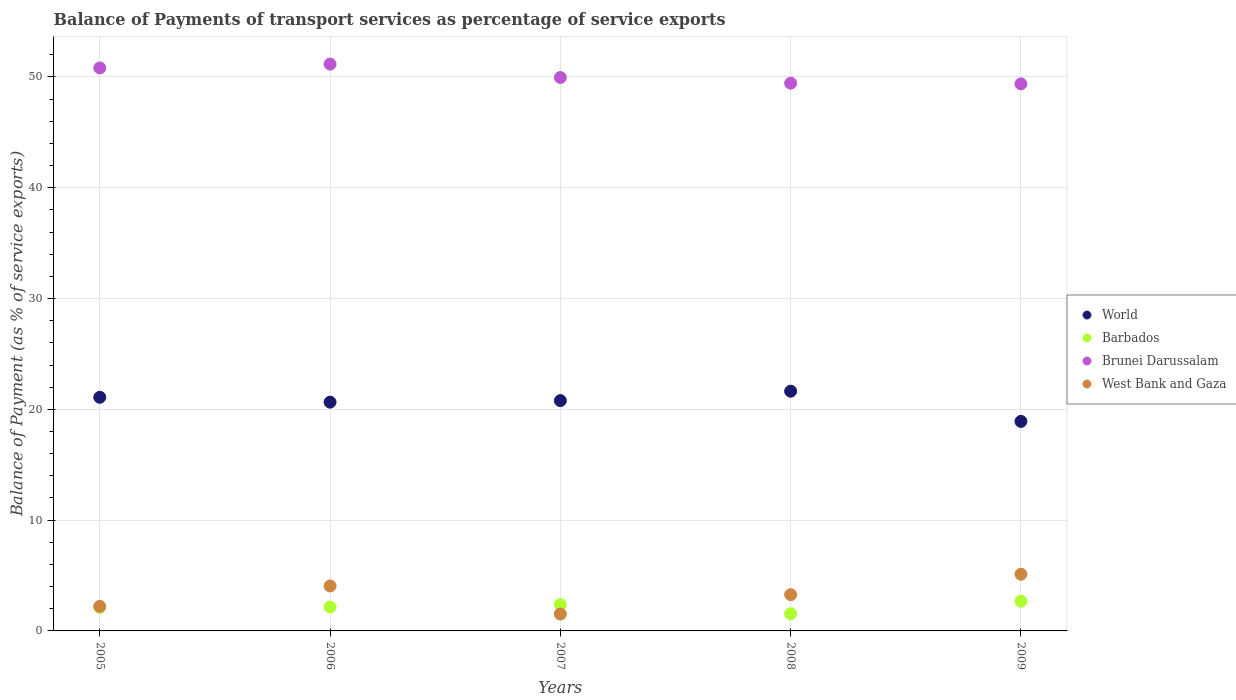How many different coloured dotlines are there?
Ensure brevity in your answer.  4. What is the balance of payments of transport services in World in 2007?
Provide a succinct answer. 20.79. Across all years, what is the maximum balance of payments of transport services in Barbados?
Provide a short and direct response. 2.68. Across all years, what is the minimum balance of payments of transport services in Barbados?
Keep it short and to the point. 1.55. In which year was the balance of payments of transport services in Brunei Darussalam maximum?
Ensure brevity in your answer.  2006. In which year was the balance of payments of transport services in Brunei Darussalam minimum?
Keep it short and to the point. 2009. What is the total balance of payments of transport services in West Bank and Gaza in the graph?
Your answer should be very brief. 16.19. What is the difference between the balance of payments of transport services in West Bank and Gaza in 2005 and that in 2009?
Your answer should be very brief. -2.9. What is the difference between the balance of payments of transport services in World in 2007 and the balance of payments of transport services in Brunei Darussalam in 2009?
Provide a short and direct response. -28.59. What is the average balance of payments of transport services in World per year?
Keep it short and to the point. 20.61. In the year 2009, what is the difference between the balance of payments of transport services in Brunei Darussalam and balance of payments of transport services in West Bank and Gaza?
Offer a terse response. 44.26. What is the ratio of the balance of payments of transport services in Barbados in 2007 to that in 2009?
Your answer should be very brief. 0.88. What is the difference between the highest and the second highest balance of payments of transport services in World?
Ensure brevity in your answer.  0.55. What is the difference between the highest and the lowest balance of payments of transport services in World?
Give a very brief answer. 2.73. Is the sum of the balance of payments of transport services in Brunei Darussalam in 2006 and 2007 greater than the maximum balance of payments of transport services in Barbados across all years?
Your answer should be compact. Yes. Is it the case that in every year, the sum of the balance of payments of transport services in Brunei Darussalam and balance of payments of transport services in World  is greater than the balance of payments of transport services in West Bank and Gaza?
Your response must be concise. Yes. Is the balance of payments of transport services in World strictly greater than the balance of payments of transport services in West Bank and Gaza over the years?
Give a very brief answer. Yes. How many dotlines are there?
Your response must be concise. 4. What is the difference between two consecutive major ticks on the Y-axis?
Keep it short and to the point. 10. Are the values on the major ticks of Y-axis written in scientific E-notation?
Offer a terse response. No. Does the graph contain grids?
Keep it short and to the point. Yes. Where does the legend appear in the graph?
Your answer should be compact. Center right. How are the legend labels stacked?
Give a very brief answer. Vertical. What is the title of the graph?
Your response must be concise. Balance of Payments of transport services as percentage of service exports. Does "Solomon Islands" appear as one of the legend labels in the graph?
Your answer should be compact. No. What is the label or title of the X-axis?
Give a very brief answer. Years. What is the label or title of the Y-axis?
Give a very brief answer. Balance of Payment (as % of service exports). What is the Balance of Payment (as % of service exports) of World in 2005?
Ensure brevity in your answer.  21.09. What is the Balance of Payment (as % of service exports) in Barbados in 2005?
Your answer should be very brief. 2.13. What is the Balance of Payment (as % of service exports) of Brunei Darussalam in 2005?
Your answer should be very brief. 50.81. What is the Balance of Payment (as % of service exports) of West Bank and Gaza in 2005?
Offer a very short reply. 2.21. What is the Balance of Payment (as % of service exports) of World in 2006?
Ensure brevity in your answer.  20.65. What is the Balance of Payment (as % of service exports) of Barbados in 2006?
Ensure brevity in your answer.  2.15. What is the Balance of Payment (as % of service exports) in Brunei Darussalam in 2006?
Ensure brevity in your answer.  51.16. What is the Balance of Payment (as % of service exports) of West Bank and Gaza in 2006?
Ensure brevity in your answer.  4.06. What is the Balance of Payment (as % of service exports) in World in 2007?
Keep it short and to the point. 20.79. What is the Balance of Payment (as % of service exports) in Barbados in 2007?
Provide a succinct answer. 2.37. What is the Balance of Payment (as % of service exports) in Brunei Darussalam in 2007?
Your response must be concise. 49.95. What is the Balance of Payment (as % of service exports) of West Bank and Gaza in 2007?
Your answer should be very brief. 1.53. What is the Balance of Payment (as % of service exports) of World in 2008?
Offer a very short reply. 21.64. What is the Balance of Payment (as % of service exports) of Barbados in 2008?
Make the answer very short. 1.55. What is the Balance of Payment (as % of service exports) in Brunei Darussalam in 2008?
Your response must be concise. 49.44. What is the Balance of Payment (as % of service exports) of West Bank and Gaza in 2008?
Provide a succinct answer. 3.27. What is the Balance of Payment (as % of service exports) of World in 2009?
Make the answer very short. 18.91. What is the Balance of Payment (as % of service exports) of Barbados in 2009?
Offer a very short reply. 2.68. What is the Balance of Payment (as % of service exports) of Brunei Darussalam in 2009?
Provide a succinct answer. 49.38. What is the Balance of Payment (as % of service exports) in West Bank and Gaza in 2009?
Provide a short and direct response. 5.12. Across all years, what is the maximum Balance of Payment (as % of service exports) in World?
Offer a terse response. 21.64. Across all years, what is the maximum Balance of Payment (as % of service exports) in Barbados?
Provide a succinct answer. 2.68. Across all years, what is the maximum Balance of Payment (as % of service exports) in Brunei Darussalam?
Offer a very short reply. 51.16. Across all years, what is the maximum Balance of Payment (as % of service exports) in West Bank and Gaza?
Ensure brevity in your answer.  5.12. Across all years, what is the minimum Balance of Payment (as % of service exports) of World?
Your response must be concise. 18.91. Across all years, what is the minimum Balance of Payment (as % of service exports) of Barbados?
Offer a very short reply. 1.55. Across all years, what is the minimum Balance of Payment (as % of service exports) in Brunei Darussalam?
Your response must be concise. 49.38. Across all years, what is the minimum Balance of Payment (as % of service exports) of West Bank and Gaza?
Keep it short and to the point. 1.53. What is the total Balance of Payment (as % of service exports) in World in the graph?
Provide a short and direct response. 103.07. What is the total Balance of Payment (as % of service exports) in Barbados in the graph?
Give a very brief answer. 10.89. What is the total Balance of Payment (as % of service exports) in Brunei Darussalam in the graph?
Ensure brevity in your answer.  250.74. What is the total Balance of Payment (as % of service exports) in West Bank and Gaza in the graph?
Your answer should be very brief. 16.19. What is the difference between the Balance of Payment (as % of service exports) in World in 2005 and that in 2006?
Provide a short and direct response. 0.44. What is the difference between the Balance of Payment (as % of service exports) of Barbados in 2005 and that in 2006?
Ensure brevity in your answer.  -0.02. What is the difference between the Balance of Payment (as % of service exports) in Brunei Darussalam in 2005 and that in 2006?
Your answer should be compact. -0.35. What is the difference between the Balance of Payment (as % of service exports) of West Bank and Gaza in 2005 and that in 2006?
Offer a terse response. -1.84. What is the difference between the Balance of Payment (as % of service exports) of World in 2005 and that in 2007?
Your response must be concise. 0.3. What is the difference between the Balance of Payment (as % of service exports) in Barbados in 2005 and that in 2007?
Give a very brief answer. -0.24. What is the difference between the Balance of Payment (as % of service exports) in Brunei Darussalam in 2005 and that in 2007?
Make the answer very short. 0.86. What is the difference between the Balance of Payment (as % of service exports) of West Bank and Gaza in 2005 and that in 2007?
Your answer should be compact. 0.69. What is the difference between the Balance of Payment (as % of service exports) of World in 2005 and that in 2008?
Your response must be concise. -0.55. What is the difference between the Balance of Payment (as % of service exports) of Barbados in 2005 and that in 2008?
Make the answer very short. 0.58. What is the difference between the Balance of Payment (as % of service exports) of Brunei Darussalam in 2005 and that in 2008?
Provide a succinct answer. 1.38. What is the difference between the Balance of Payment (as % of service exports) in West Bank and Gaza in 2005 and that in 2008?
Keep it short and to the point. -1.06. What is the difference between the Balance of Payment (as % of service exports) in World in 2005 and that in 2009?
Your answer should be very brief. 2.18. What is the difference between the Balance of Payment (as % of service exports) of Barbados in 2005 and that in 2009?
Provide a succinct answer. -0.56. What is the difference between the Balance of Payment (as % of service exports) of Brunei Darussalam in 2005 and that in 2009?
Offer a terse response. 1.44. What is the difference between the Balance of Payment (as % of service exports) of West Bank and Gaza in 2005 and that in 2009?
Your answer should be compact. -2.9. What is the difference between the Balance of Payment (as % of service exports) of World in 2006 and that in 2007?
Offer a very short reply. -0.14. What is the difference between the Balance of Payment (as % of service exports) in Barbados in 2006 and that in 2007?
Your response must be concise. -0.22. What is the difference between the Balance of Payment (as % of service exports) in Brunei Darussalam in 2006 and that in 2007?
Your response must be concise. 1.21. What is the difference between the Balance of Payment (as % of service exports) of West Bank and Gaza in 2006 and that in 2007?
Provide a succinct answer. 2.53. What is the difference between the Balance of Payment (as % of service exports) in World in 2006 and that in 2008?
Your answer should be compact. -0.99. What is the difference between the Balance of Payment (as % of service exports) of Barbados in 2006 and that in 2008?
Offer a very short reply. 0.6. What is the difference between the Balance of Payment (as % of service exports) in Brunei Darussalam in 2006 and that in 2008?
Ensure brevity in your answer.  1.73. What is the difference between the Balance of Payment (as % of service exports) in West Bank and Gaza in 2006 and that in 2008?
Keep it short and to the point. 0.78. What is the difference between the Balance of Payment (as % of service exports) in World in 2006 and that in 2009?
Make the answer very short. 1.74. What is the difference between the Balance of Payment (as % of service exports) of Barbados in 2006 and that in 2009?
Provide a succinct answer. -0.53. What is the difference between the Balance of Payment (as % of service exports) of Brunei Darussalam in 2006 and that in 2009?
Offer a terse response. 1.79. What is the difference between the Balance of Payment (as % of service exports) of West Bank and Gaza in 2006 and that in 2009?
Make the answer very short. -1.06. What is the difference between the Balance of Payment (as % of service exports) of World in 2007 and that in 2008?
Ensure brevity in your answer.  -0.85. What is the difference between the Balance of Payment (as % of service exports) in Barbados in 2007 and that in 2008?
Ensure brevity in your answer.  0.82. What is the difference between the Balance of Payment (as % of service exports) of Brunei Darussalam in 2007 and that in 2008?
Provide a succinct answer. 0.51. What is the difference between the Balance of Payment (as % of service exports) in West Bank and Gaza in 2007 and that in 2008?
Your answer should be compact. -1.75. What is the difference between the Balance of Payment (as % of service exports) of World in 2007 and that in 2009?
Your answer should be very brief. 1.88. What is the difference between the Balance of Payment (as % of service exports) of Barbados in 2007 and that in 2009?
Provide a short and direct response. -0.31. What is the difference between the Balance of Payment (as % of service exports) of Brunei Darussalam in 2007 and that in 2009?
Ensure brevity in your answer.  0.57. What is the difference between the Balance of Payment (as % of service exports) of West Bank and Gaza in 2007 and that in 2009?
Provide a short and direct response. -3.59. What is the difference between the Balance of Payment (as % of service exports) of World in 2008 and that in 2009?
Offer a terse response. 2.73. What is the difference between the Balance of Payment (as % of service exports) of Barbados in 2008 and that in 2009?
Provide a short and direct response. -1.13. What is the difference between the Balance of Payment (as % of service exports) in West Bank and Gaza in 2008 and that in 2009?
Give a very brief answer. -1.85. What is the difference between the Balance of Payment (as % of service exports) in World in 2005 and the Balance of Payment (as % of service exports) in Barbados in 2006?
Make the answer very short. 18.94. What is the difference between the Balance of Payment (as % of service exports) in World in 2005 and the Balance of Payment (as % of service exports) in Brunei Darussalam in 2006?
Keep it short and to the point. -30.07. What is the difference between the Balance of Payment (as % of service exports) of World in 2005 and the Balance of Payment (as % of service exports) of West Bank and Gaza in 2006?
Offer a very short reply. 17.03. What is the difference between the Balance of Payment (as % of service exports) in Barbados in 2005 and the Balance of Payment (as % of service exports) in Brunei Darussalam in 2006?
Your answer should be compact. -49.03. What is the difference between the Balance of Payment (as % of service exports) of Barbados in 2005 and the Balance of Payment (as % of service exports) of West Bank and Gaza in 2006?
Keep it short and to the point. -1.93. What is the difference between the Balance of Payment (as % of service exports) of Brunei Darussalam in 2005 and the Balance of Payment (as % of service exports) of West Bank and Gaza in 2006?
Offer a terse response. 46.76. What is the difference between the Balance of Payment (as % of service exports) in World in 2005 and the Balance of Payment (as % of service exports) in Barbados in 2007?
Provide a succinct answer. 18.71. What is the difference between the Balance of Payment (as % of service exports) of World in 2005 and the Balance of Payment (as % of service exports) of Brunei Darussalam in 2007?
Provide a short and direct response. -28.86. What is the difference between the Balance of Payment (as % of service exports) in World in 2005 and the Balance of Payment (as % of service exports) in West Bank and Gaza in 2007?
Provide a succinct answer. 19.56. What is the difference between the Balance of Payment (as % of service exports) of Barbados in 2005 and the Balance of Payment (as % of service exports) of Brunei Darussalam in 2007?
Offer a terse response. -47.82. What is the difference between the Balance of Payment (as % of service exports) of Barbados in 2005 and the Balance of Payment (as % of service exports) of West Bank and Gaza in 2007?
Keep it short and to the point. 0.6. What is the difference between the Balance of Payment (as % of service exports) of Brunei Darussalam in 2005 and the Balance of Payment (as % of service exports) of West Bank and Gaza in 2007?
Provide a succinct answer. 49.29. What is the difference between the Balance of Payment (as % of service exports) of World in 2005 and the Balance of Payment (as % of service exports) of Barbados in 2008?
Your response must be concise. 19.54. What is the difference between the Balance of Payment (as % of service exports) of World in 2005 and the Balance of Payment (as % of service exports) of Brunei Darussalam in 2008?
Provide a succinct answer. -28.35. What is the difference between the Balance of Payment (as % of service exports) in World in 2005 and the Balance of Payment (as % of service exports) in West Bank and Gaza in 2008?
Provide a short and direct response. 17.82. What is the difference between the Balance of Payment (as % of service exports) of Barbados in 2005 and the Balance of Payment (as % of service exports) of Brunei Darussalam in 2008?
Ensure brevity in your answer.  -47.31. What is the difference between the Balance of Payment (as % of service exports) of Barbados in 2005 and the Balance of Payment (as % of service exports) of West Bank and Gaza in 2008?
Your answer should be compact. -1.14. What is the difference between the Balance of Payment (as % of service exports) of Brunei Darussalam in 2005 and the Balance of Payment (as % of service exports) of West Bank and Gaza in 2008?
Provide a succinct answer. 47.54. What is the difference between the Balance of Payment (as % of service exports) of World in 2005 and the Balance of Payment (as % of service exports) of Barbados in 2009?
Ensure brevity in your answer.  18.4. What is the difference between the Balance of Payment (as % of service exports) of World in 2005 and the Balance of Payment (as % of service exports) of Brunei Darussalam in 2009?
Make the answer very short. -28.29. What is the difference between the Balance of Payment (as % of service exports) in World in 2005 and the Balance of Payment (as % of service exports) in West Bank and Gaza in 2009?
Your answer should be compact. 15.97. What is the difference between the Balance of Payment (as % of service exports) in Barbados in 2005 and the Balance of Payment (as % of service exports) in Brunei Darussalam in 2009?
Keep it short and to the point. -47.25. What is the difference between the Balance of Payment (as % of service exports) of Barbados in 2005 and the Balance of Payment (as % of service exports) of West Bank and Gaza in 2009?
Give a very brief answer. -2.99. What is the difference between the Balance of Payment (as % of service exports) of Brunei Darussalam in 2005 and the Balance of Payment (as % of service exports) of West Bank and Gaza in 2009?
Make the answer very short. 45.7. What is the difference between the Balance of Payment (as % of service exports) in World in 2006 and the Balance of Payment (as % of service exports) in Barbados in 2007?
Give a very brief answer. 18.28. What is the difference between the Balance of Payment (as % of service exports) in World in 2006 and the Balance of Payment (as % of service exports) in Brunei Darussalam in 2007?
Keep it short and to the point. -29.3. What is the difference between the Balance of Payment (as % of service exports) in World in 2006 and the Balance of Payment (as % of service exports) in West Bank and Gaza in 2007?
Keep it short and to the point. 19.12. What is the difference between the Balance of Payment (as % of service exports) in Barbados in 2006 and the Balance of Payment (as % of service exports) in Brunei Darussalam in 2007?
Your answer should be compact. -47.8. What is the difference between the Balance of Payment (as % of service exports) in Barbados in 2006 and the Balance of Payment (as % of service exports) in West Bank and Gaza in 2007?
Provide a succinct answer. 0.62. What is the difference between the Balance of Payment (as % of service exports) of Brunei Darussalam in 2006 and the Balance of Payment (as % of service exports) of West Bank and Gaza in 2007?
Your response must be concise. 49.63. What is the difference between the Balance of Payment (as % of service exports) of World in 2006 and the Balance of Payment (as % of service exports) of Barbados in 2008?
Make the answer very short. 19.1. What is the difference between the Balance of Payment (as % of service exports) in World in 2006 and the Balance of Payment (as % of service exports) in Brunei Darussalam in 2008?
Keep it short and to the point. -28.79. What is the difference between the Balance of Payment (as % of service exports) in World in 2006 and the Balance of Payment (as % of service exports) in West Bank and Gaza in 2008?
Keep it short and to the point. 17.38. What is the difference between the Balance of Payment (as % of service exports) in Barbados in 2006 and the Balance of Payment (as % of service exports) in Brunei Darussalam in 2008?
Keep it short and to the point. -47.28. What is the difference between the Balance of Payment (as % of service exports) of Barbados in 2006 and the Balance of Payment (as % of service exports) of West Bank and Gaza in 2008?
Provide a succinct answer. -1.12. What is the difference between the Balance of Payment (as % of service exports) of Brunei Darussalam in 2006 and the Balance of Payment (as % of service exports) of West Bank and Gaza in 2008?
Offer a terse response. 47.89. What is the difference between the Balance of Payment (as % of service exports) of World in 2006 and the Balance of Payment (as % of service exports) of Barbados in 2009?
Ensure brevity in your answer.  17.96. What is the difference between the Balance of Payment (as % of service exports) in World in 2006 and the Balance of Payment (as % of service exports) in Brunei Darussalam in 2009?
Your response must be concise. -28.73. What is the difference between the Balance of Payment (as % of service exports) in World in 2006 and the Balance of Payment (as % of service exports) in West Bank and Gaza in 2009?
Make the answer very short. 15.53. What is the difference between the Balance of Payment (as % of service exports) in Barbados in 2006 and the Balance of Payment (as % of service exports) in Brunei Darussalam in 2009?
Offer a terse response. -47.22. What is the difference between the Balance of Payment (as % of service exports) in Barbados in 2006 and the Balance of Payment (as % of service exports) in West Bank and Gaza in 2009?
Give a very brief answer. -2.97. What is the difference between the Balance of Payment (as % of service exports) of Brunei Darussalam in 2006 and the Balance of Payment (as % of service exports) of West Bank and Gaza in 2009?
Offer a very short reply. 46.04. What is the difference between the Balance of Payment (as % of service exports) in World in 2007 and the Balance of Payment (as % of service exports) in Barbados in 2008?
Your answer should be compact. 19.24. What is the difference between the Balance of Payment (as % of service exports) of World in 2007 and the Balance of Payment (as % of service exports) of Brunei Darussalam in 2008?
Your answer should be compact. -28.65. What is the difference between the Balance of Payment (as % of service exports) of World in 2007 and the Balance of Payment (as % of service exports) of West Bank and Gaza in 2008?
Your answer should be very brief. 17.52. What is the difference between the Balance of Payment (as % of service exports) of Barbados in 2007 and the Balance of Payment (as % of service exports) of Brunei Darussalam in 2008?
Provide a short and direct response. -47.06. What is the difference between the Balance of Payment (as % of service exports) of Barbados in 2007 and the Balance of Payment (as % of service exports) of West Bank and Gaza in 2008?
Your answer should be very brief. -0.9. What is the difference between the Balance of Payment (as % of service exports) of Brunei Darussalam in 2007 and the Balance of Payment (as % of service exports) of West Bank and Gaza in 2008?
Ensure brevity in your answer.  46.68. What is the difference between the Balance of Payment (as % of service exports) in World in 2007 and the Balance of Payment (as % of service exports) in Barbados in 2009?
Your answer should be compact. 18.1. What is the difference between the Balance of Payment (as % of service exports) of World in 2007 and the Balance of Payment (as % of service exports) of Brunei Darussalam in 2009?
Give a very brief answer. -28.59. What is the difference between the Balance of Payment (as % of service exports) in World in 2007 and the Balance of Payment (as % of service exports) in West Bank and Gaza in 2009?
Give a very brief answer. 15.67. What is the difference between the Balance of Payment (as % of service exports) of Barbados in 2007 and the Balance of Payment (as % of service exports) of Brunei Darussalam in 2009?
Keep it short and to the point. -47. What is the difference between the Balance of Payment (as % of service exports) of Barbados in 2007 and the Balance of Payment (as % of service exports) of West Bank and Gaza in 2009?
Give a very brief answer. -2.74. What is the difference between the Balance of Payment (as % of service exports) in Brunei Darussalam in 2007 and the Balance of Payment (as % of service exports) in West Bank and Gaza in 2009?
Give a very brief answer. 44.83. What is the difference between the Balance of Payment (as % of service exports) in World in 2008 and the Balance of Payment (as % of service exports) in Barbados in 2009?
Provide a short and direct response. 18.95. What is the difference between the Balance of Payment (as % of service exports) of World in 2008 and the Balance of Payment (as % of service exports) of Brunei Darussalam in 2009?
Make the answer very short. -27.74. What is the difference between the Balance of Payment (as % of service exports) in World in 2008 and the Balance of Payment (as % of service exports) in West Bank and Gaza in 2009?
Your answer should be very brief. 16.52. What is the difference between the Balance of Payment (as % of service exports) in Barbados in 2008 and the Balance of Payment (as % of service exports) in Brunei Darussalam in 2009?
Keep it short and to the point. -47.83. What is the difference between the Balance of Payment (as % of service exports) of Barbados in 2008 and the Balance of Payment (as % of service exports) of West Bank and Gaza in 2009?
Make the answer very short. -3.57. What is the difference between the Balance of Payment (as % of service exports) in Brunei Darussalam in 2008 and the Balance of Payment (as % of service exports) in West Bank and Gaza in 2009?
Your answer should be compact. 44.32. What is the average Balance of Payment (as % of service exports) in World per year?
Offer a very short reply. 20.61. What is the average Balance of Payment (as % of service exports) of Barbados per year?
Your answer should be compact. 2.18. What is the average Balance of Payment (as % of service exports) of Brunei Darussalam per year?
Offer a very short reply. 50.15. What is the average Balance of Payment (as % of service exports) of West Bank and Gaza per year?
Ensure brevity in your answer.  3.24. In the year 2005, what is the difference between the Balance of Payment (as % of service exports) of World and Balance of Payment (as % of service exports) of Barbados?
Offer a very short reply. 18.96. In the year 2005, what is the difference between the Balance of Payment (as % of service exports) in World and Balance of Payment (as % of service exports) in Brunei Darussalam?
Provide a succinct answer. -29.73. In the year 2005, what is the difference between the Balance of Payment (as % of service exports) in World and Balance of Payment (as % of service exports) in West Bank and Gaza?
Ensure brevity in your answer.  18.87. In the year 2005, what is the difference between the Balance of Payment (as % of service exports) in Barbados and Balance of Payment (as % of service exports) in Brunei Darussalam?
Give a very brief answer. -48.69. In the year 2005, what is the difference between the Balance of Payment (as % of service exports) of Barbados and Balance of Payment (as % of service exports) of West Bank and Gaza?
Provide a succinct answer. -0.09. In the year 2005, what is the difference between the Balance of Payment (as % of service exports) in Brunei Darussalam and Balance of Payment (as % of service exports) in West Bank and Gaza?
Your response must be concise. 48.6. In the year 2006, what is the difference between the Balance of Payment (as % of service exports) in World and Balance of Payment (as % of service exports) in Barbados?
Your answer should be compact. 18.5. In the year 2006, what is the difference between the Balance of Payment (as % of service exports) in World and Balance of Payment (as % of service exports) in Brunei Darussalam?
Offer a very short reply. -30.51. In the year 2006, what is the difference between the Balance of Payment (as % of service exports) of World and Balance of Payment (as % of service exports) of West Bank and Gaza?
Offer a very short reply. 16.59. In the year 2006, what is the difference between the Balance of Payment (as % of service exports) in Barbados and Balance of Payment (as % of service exports) in Brunei Darussalam?
Make the answer very short. -49.01. In the year 2006, what is the difference between the Balance of Payment (as % of service exports) in Barbados and Balance of Payment (as % of service exports) in West Bank and Gaza?
Give a very brief answer. -1.91. In the year 2006, what is the difference between the Balance of Payment (as % of service exports) of Brunei Darussalam and Balance of Payment (as % of service exports) of West Bank and Gaza?
Offer a terse response. 47.1. In the year 2007, what is the difference between the Balance of Payment (as % of service exports) of World and Balance of Payment (as % of service exports) of Barbados?
Offer a terse response. 18.41. In the year 2007, what is the difference between the Balance of Payment (as % of service exports) of World and Balance of Payment (as % of service exports) of Brunei Darussalam?
Make the answer very short. -29.16. In the year 2007, what is the difference between the Balance of Payment (as % of service exports) of World and Balance of Payment (as % of service exports) of West Bank and Gaza?
Make the answer very short. 19.26. In the year 2007, what is the difference between the Balance of Payment (as % of service exports) of Barbados and Balance of Payment (as % of service exports) of Brunei Darussalam?
Make the answer very short. -47.58. In the year 2007, what is the difference between the Balance of Payment (as % of service exports) in Barbados and Balance of Payment (as % of service exports) in West Bank and Gaza?
Provide a succinct answer. 0.85. In the year 2007, what is the difference between the Balance of Payment (as % of service exports) in Brunei Darussalam and Balance of Payment (as % of service exports) in West Bank and Gaza?
Your response must be concise. 48.42. In the year 2008, what is the difference between the Balance of Payment (as % of service exports) in World and Balance of Payment (as % of service exports) in Barbados?
Your answer should be compact. 20.09. In the year 2008, what is the difference between the Balance of Payment (as % of service exports) in World and Balance of Payment (as % of service exports) in Brunei Darussalam?
Give a very brief answer. -27.8. In the year 2008, what is the difference between the Balance of Payment (as % of service exports) in World and Balance of Payment (as % of service exports) in West Bank and Gaza?
Your response must be concise. 18.36. In the year 2008, what is the difference between the Balance of Payment (as % of service exports) in Barbados and Balance of Payment (as % of service exports) in Brunei Darussalam?
Give a very brief answer. -47.89. In the year 2008, what is the difference between the Balance of Payment (as % of service exports) of Barbados and Balance of Payment (as % of service exports) of West Bank and Gaza?
Keep it short and to the point. -1.72. In the year 2008, what is the difference between the Balance of Payment (as % of service exports) of Brunei Darussalam and Balance of Payment (as % of service exports) of West Bank and Gaza?
Give a very brief answer. 46.16. In the year 2009, what is the difference between the Balance of Payment (as % of service exports) in World and Balance of Payment (as % of service exports) in Barbados?
Provide a short and direct response. 16.23. In the year 2009, what is the difference between the Balance of Payment (as % of service exports) of World and Balance of Payment (as % of service exports) of Brunei Darussalam?
Offer a very short reply. -30.46. In the year 2009, what is the difference between the Balance of Payment (as % of service exports) of World and Balance of Payment (as % of service exports) of West Bank and Gaza?
Your response must be concise. 13.79. In the year 2009, what is the difference between the Balance of Payment (as % of service exports) in Barbados and Balance of Payment (as % of service exports) in Brunei Darussalam?
Provide a succinct answer. -46.69. In the year 2009, what is the difference between the Balance of Payment (as % of service exports) of Barbados and Balance of Payment (as % of service exports) of West Bank and Gaza?
Offer a very short reply. -2.43. In the year 2009, what is the difference between the Balance of Payment (as % of service exports) of Brunei Darussalam and Balance of Payment (as % of service exports) of West Bank and Gaza?
Provide a succinct answer. 44.26. What is the ratio of the Balance of Payment (as % of service exports) in World in 2005 to that in 2006?
Make the answer very short. 1.02. What is the ratio of the Balance of Payment (as % of service exports) in West Bank and Gaza in 2005 to that in 2006?
Keep it short and to the point. 0.55. What is the ratio of the Balance of Payment (as % of service exports) of World in 2005 to that in 2007?
Keep it short and to the point. 1.01. What is the ratio of the Balance of Payment (as % of service exports) of Barbados in 2005 to that in 2007?
Offer a terse response. 0.9. What is the ratio of the Balance of Payment (as % of service exports) of Brunei Darussalam in 2005 to that in 2007?
Your answer should be compact. 1.02. What is the ratio of the Balance of Payment (as % of service exports) of West Bank and Gaza in 2005 to that in 2007?
Offer a terse response. 1.45. What is the ratio of the Balance of Payment (as % of service exports) of World in 2005 to that in 2008?
Make the answer very short. 0.97. What is the ratio of the Balance of Payment (as % of service exports) of Barbados in 2005 to that in 2008?
Give a very brief answer. 1.37. What is the ratio of the Balance of Payment (as % of service exports) in Brunei Darussalam in 2005 to that in 2008?
Offer a very short reply. 1.03. What is the ratio of the Balance of Payment (as % of service exports) in West Bank and Gaza in 2005 to that in 2008?
Your response must be concise. 0.68. What is the ratio of the Balance of Payment (as % of service exports) of World in 2005 to that in 2009?
Ensure brevity in your answer.  1.12. What is the ratio of the Balance of Payment (as % of service exports) of Barbados in 2005 to that in 2009?
Offer a terse response. 0.79. What is the ratio of the Balance of Payment (as % of service exports) in Brunei Darussalam in 2005 to that in 2009?
Provide a succinct answer. 1.03. What is the ratio of the Balance of Payment (as % of service exports) in West Bank and Gaza in 2005 to that in 2009?
Give a very brief answer. 0.43. What is the ratio of the Balance of Payment (as % of service exports) of World in 2006 to that in 2007?
Your response must be concise. 0.99. What is the ratio of the Balance of Payment (as % of service exports) of Barbados in 2006 to that in 2007?
Ensure brevity in your answer.  0.91. What is the ratio of the Balance of Payment (as % of service exports) in Brunei Darussalam in 2006 to that in 2007?
Provide a succinct answer. 1.02. What is the ratio of the Balance of Payment (as % of service exports) of West Bank and Gaza in 2006 to that in 2007?
Ensure brevity in your answer.  2.66. What is the ratio of the Balance of Payment (as % of service exports) in World in 2006 to that in 2008?
Give a very brief answer. 0.95. What is the ratio of the Balance of Payment (as % of service exports) in Barbados in 2006 to that in 2008?
Your response must be concise. 1.39. What is the ratio of the Balance of Payment (as % of service exports) of Brunei Darussalam in 2006 to that in 2008?
Offer a terse response. 1.03. What is the ratio of the Balance of Payment (as % of service exports) of West Bank and Gaza in 2006 to that in 2008?
Ensure brevity in your answer.  1.24. What is the ratio of the Balance of Payment (as % of service exports) in World in 2006 to that in 2009?
Provide a succinct answer. 1.09. What is the ratio of the Balance of Payment (as % of service exports) in Barbados in 2006 to that in 2009?
Keep it short and to the point. 0.8. What is the ratio of the Balance of Payment (as % of service exports) of Brunei Darussalam in 2006 to that in 2009?
Offer a terse response. 1.04. What is the ratio of the Balance of Payment (as % of service exports) in West Bank and Gaza in 2006 to that in 2009?
Your answer should be compact. 0.79. What is the ratio of the Balance of Payment (as % of service exports) in World in 2007 to that in 2008?
Offer a terse response. 0.96. What is the ratio of the Balance of Payment (as % of service exports) of Barbados in 2007 to that in 2008?
Provide a succinct answer. 1.53. What is the ratio of the Balance of Payment (as % of service exports) in Brunei Darussalam in 2007 to that in 2008?
Offer a very short reply. 1.01. What is the ratio of the Balance of Payment (as % of service exports) of West Bank and Gaza in 2007 to that in 2008?
Provide a succinct answer. 0.47. What is the ratio of the Balance of Payment (as % of service exports) in World in 2007 to that in 2009?
Your response must be concise. 1.1. What is the ratio of the Balance of Payment (as % of service exports) in Barbados in 2007 to that in 2009?
Ensure brevity in your answer.  0.88. What is the ratio of the Balance of Payment (as % of service exports) of Brunei Darussalam in 2007 to that in 2009?
Offer a terse response. 1.01. What is the ratio of the Balance of Payment (as % of service exports) of West Bank and Gaza in 2007 to that in 2009?
Your response must be concise. 0.3. What is the ratio of the Balance of Payment (as % of service exports) of World in 2008 to that in 2009?
Provide a succinct answer. 1.14. What is the ratio of the Balance of Payment (as % of service exports) in Barbados in 2008 to that in 2009?
Give a very brief answer. 0.58. What is the ratio of the Balance of Payment (as % of service exports) in Brunei Darussalam in 2008 to that in 2009?
Your response must be concise. 1. What is the ratio of the Balance of Payment (as % of service exports) in West Bank and Gaza in 2008 to that in 2009?
Provide a short and direct response. 0.64. What is the difference between the highest and the second highest Balance of Payment (as % of service exports) in World?
Provide a short and direct response. 0.55. What is the difference between the highest and the second highest Balance of Payment (as % of service exports) of Barbados?
Ensure brevity in your answer.  0.31. What is the difference between the highest and the second highest Balance of Payment (as % of service exports) of Brunei Darussalam?
Your response must be concise. 0.35. What is the difference between the highest and the second highest Balance of Payment (as % of service exports) of West Bank and Gaza?
Your response must be concise. 1.06. What is the difference between the highest and the lowest Balance of Payment (as % of service exports) of World?
Offer a very short reply. 2.73. What is the difference between the highest and the lowest Balance of Payment (as % of service exports) of Barbados?
Your answer should be very brief. 1.13. What is the difference between the highest and the lowest Balance of Payment (as % of service exports) in Brunei Darussalam?
Offer a terse response. 1.79. What is the difference between the highest and the lowest Balance of Payment (as % of service exports) in West Bank and Gaza?
Your answer should be very brief. 3.59. 